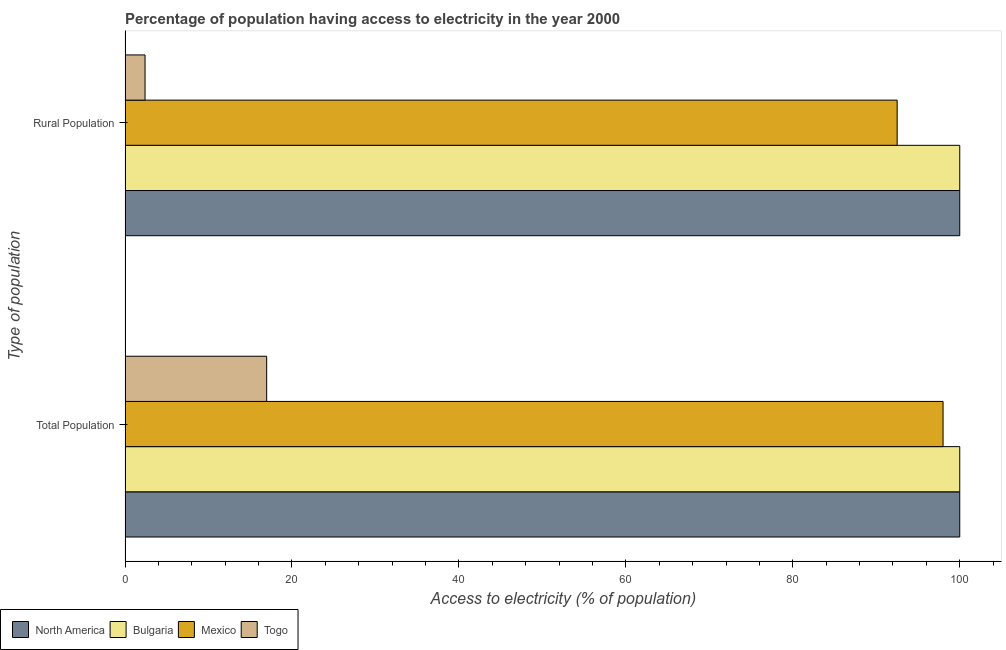How many different coloured bars are there?
Offer a terse response. 4. How many groups of bars are there?
Make the answer very short. 2. Are the number of bars per tick equal to the number of legend labels?
Give a very brief answer. Yes. How many bars are there on the 2nd tick from the bottom?
Make the answer very short. 4. What is the label of the 1st group of bars from the top?
Keep it short and to the point. Rural Population. What is the percentage of rural population having access to electricity in Mexico?
Offer a very short reply. 92.5. Across all countries, what is the minimum percentage of population having access to electricity?
Ensure brevity in your answer.  16.97. In which country was the percentage of population having access to electricity maximum?
Your response must be concise. North America. In which country was the percentage of rural population having access to electricity minimum?
Your response must be concise. Togo. What is the total percentage of rural population having access to electricity in the graph?
Ensure brevity in your answer.  294.9. What is the difference between the percentage of population having access to electricity in Bulgaria and that in Mexico?
Give a very brief answer. 2. What is the difference between the percentage of population having access to electricity in Togo and the percentage of rural population having access to electricity in Mexico?
Offer a very short reply. -75.53. What is the average percentage of rural population having access to electricity per country?
Make the answer very short. 73.72. What is the difference between the percentage of population having access to electricity and percentage of rural population having access to electricity in Togo?
Your answer should be very brief. 14.57. In how many countries, is the percentage of rural population having access to electricity greater than 76 %?
Ensure brevity in your answer.  3. What is the ratio of the percentage of population having access to electricity in Togo to that in Mexico?
Ensure brevity in your answer.  0.17. In how many countries, is the percentage of rural population having access to electricity greater than the average percentage of rural population having access to electricity taken over all countries?
Your response must be concise. 3. What does the 2nd bar from the top in Total Population represents?
Provide a succinct answer. Mexico. What does the 2nd bar from the bottom in Total Population represents?
Ensure brevity in your answer.  Bulgaria. How many bars are there?
Make the answer very short. 8. Are the values on the major ticks of X-axis written in scientific E-notation?
Offer a very short reply. No. Does the graph contain any zero values?
Your answer should be compact. No. Where does the legend appear in the graph?
Offer a terse response. Bottom left. How are the legend labels stacked?
Keep it short and to the point. Horizontal. What is the title of the graph?
Keep it short and to the point. Percentage of population having access to electricity in the year 2000. What is the label or title of the X-axis?
Your response must be concise. Access to electricity (% of population). What is the label or title of the Y-axis?
Offer a terse response. Type of population. What is the Access to electricity (% of population) in North America in Total Population?
Give a very brief answer. 100. What is the Access to electricity (% of population) of Mexico in Total Population?
Provide a short and direct response. 98. What is the Access to electricity (% of population) of Togo in Total Population?
Give a very brief answer. 16.97. What is the Access to electricity (% of population) in Bulgaria in Rural Population?
Offer a terse response. 100. What is the Access to electricity (% of population) in Mexico in Rural Population?
Your response must be concise. 92.5. Across all Type of population, what is the maximum Access to electricity (% of population) in North America?
Make the answer very short. 100. Across all Type of population, what is the maximum Access to electricity (% of population) in Bulgaria?
Provide a succinct answer. 100. Across all Type of population, what is the maximum Access to electricity (% of population) in Togo?
Make the answer very short. 16.97. Across all Type of population, what is the minimum Access to electricity (% of population) of Bulgaria?
Your response must be concise. 100. Across all Type of population, what is the minimum Access to electricity (% of population) in Mexico?
Ensure brevity in your answer.  92.5. Across all Type of population, what is the minimum Access to electricity (% of population) of Togo?
Make the answer very short. 2.4. What is the total Access to electricity (% of population) of North America in the graph?
Your answer should be compact. 200. What is the total Access to electricity (% of population) of Mexico in the graph?
Ensure brevity in your answer.  190.5. What is the total Access to electricity (% of population) in Togo in the graph?
Your answer should be very brief. 19.37. What is the difference between the Access to electricity (% of population) of Mexico in Total Population and that in Rural Population?
Make the answer very short. 5.5. What is the difference between the Access to electricity (% of population) in Togo in Total Population and that in Rural Population?
Make the answer very short. 14.57. What is the difference between the Access to electricity (% of population) in North America in Total Population and the Access to electricity (% of population) in Mexico in Rural Population?
Provide a short and direct response. 7.5. What is the difference between the Access to electricity (% of population) in North America in Total Population and the Access to electricity (% of population) in Togo in Rural Population?
Your response must be concise. 97.6. What is the difference between the Access to electricity (% of population) in Bulgaria in Total Population and the Access to electricity (% of population) in Togo in Rural Population?
Ensure brevity in your answer.  97.6. What is the difference between the Access to electricity (% of population) in Mexico in Total Population and the Access to electricity (% of population) in Togo in Rural Population?
Provide a succinct answer. 95.6. What is the average Access to electricity (% of population) of North America per Type of population?
Give a very brief answer. 100. What is the average Access to electricity (% of population) in Mexico per Type of population?
Your answer should be compact. 95.25. What is the average Access to electricity (% of population) of Togo per Type of population?
Keep it short and to the point. 9.69. What is the difference between the Access to electricity (% of population) of North America and Access to electricity (% of population) of Mexico in Total Population?
Offer a very short reply. 2. What is the difference between the Access to electricity (% of population) in North America and Access to electricity (% of population) in Togo in Total Population?
Your answer should be very brief. 83.03. What is the difference between the Access to electricity (% of population) of Bulgaria and Access to electricity (% of population) of Mexico in Total Population?
Your response must be concise. 2. What is the difference between the Access to electricity (% of population) in Bulgaria and Access to electricity (% of population) in Togo in Total Population?
Ensure brevity in your answer.  83.03. What is the difference between the Access to electricity (% of population) in Mexico and Access to electricity (% of population) in Togo in Total Population?
Make the answer very short. 81.03. What is the difference between the Access to electricity (% of population) of North America and Access to electricity (% of population) of Mexico in Rural Population?
Your answer should be compact. 7.5. What is the difference between the Access to electricity (% of population) in North America and Access to electricity (% of population) in Togo in Rural Population?
Make the answer very short. 97.6. What is the difference between the Access to electricity (% of population) in Bulgaria and Access to electricity (% of population) in Mexico in Rural Population?
Your answer should be very brief. 7.5. What is the difference between the Access to electricity (% of population) in Bulgaria and Access to electricity (% of population) in Togo in Rural Population?
Provide a short and direct response. 97.6. What is the difference between the Access to electricity (% of population) of Mexico and Access to electricity (% of population) of Togo in Rural Population?
Give a very brief answer. 90.1. What is the ratio of the Access to electricity (% of population) of Mexico in Total Population to that in Rural Population?
Provide a succinct answer. 1.06. What is the ratio of the Access to electricity (% of population) of Togo in Total Population to that in Rural Population?
Provide a succinct answer. 7.07. What is the difference between the highest and the second highest Access to electricity (% of population) of North America?
Keep it short and to the point. 0. What is the difference between the highest and the second highest Access to electricity (% of population) in Togo?
Provide a succinct answer. 14.57. What is the difference between the highest and the lowest Access to electricity (% of population) in North America?
Make the answer very short. 0. What is the difference between the highest and the lowest Access to electricity (% of population) in Mexico?
Offer a terse response. 5.5. What is the difference between the highest and the lowest Access to electricity (% of population) of Togo?
Your answer should be very brief. 14.57. 